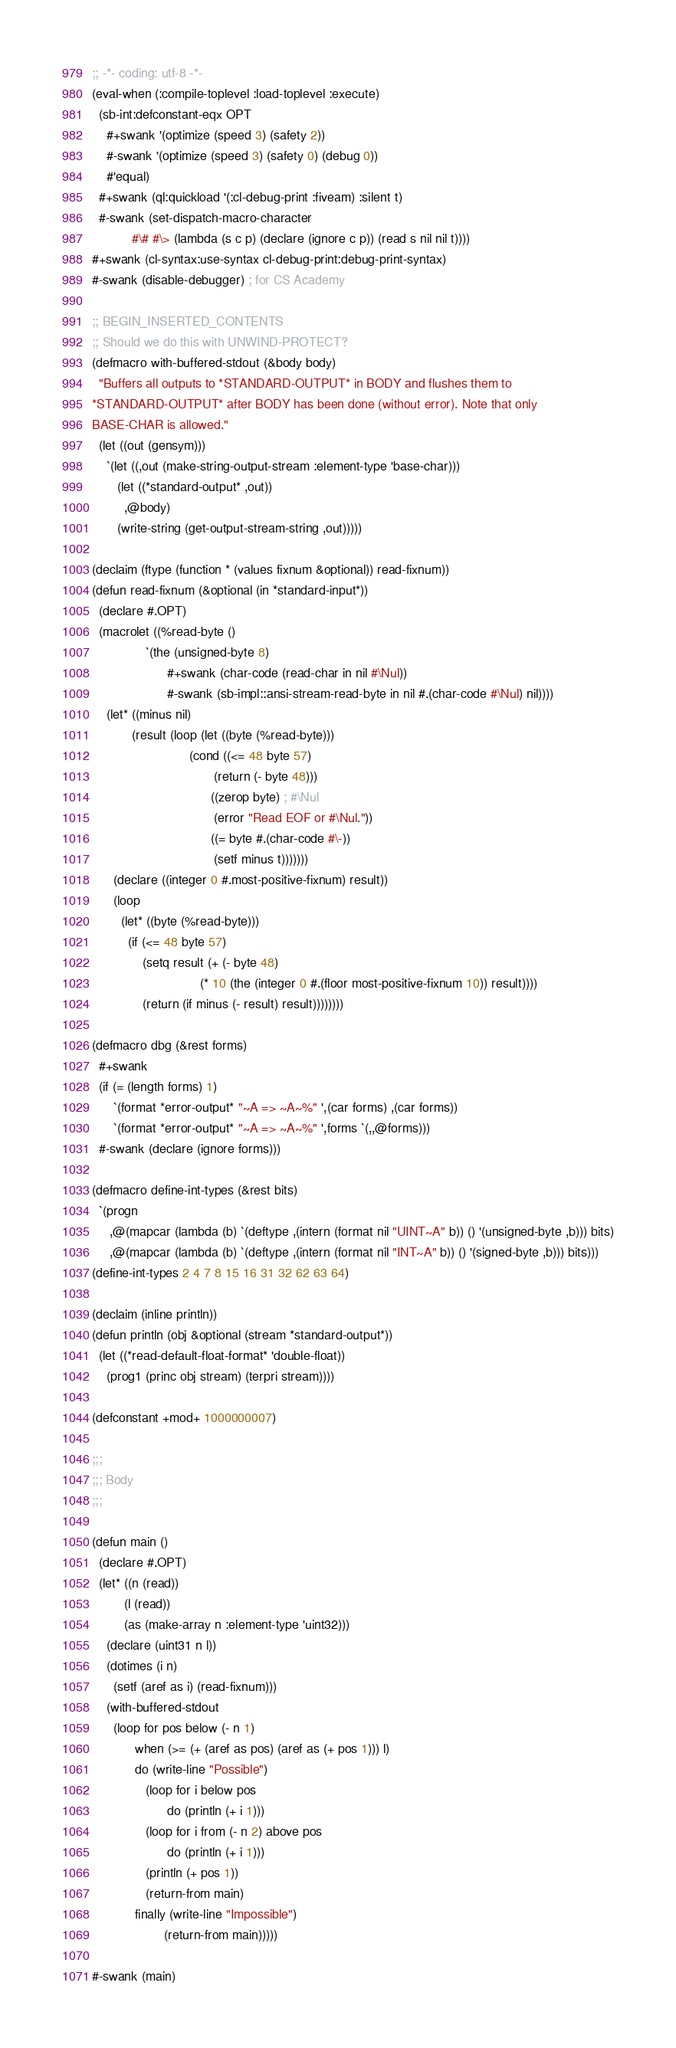<code> <loc_0><loc_0><loc_500><loc_500><_Lisp_>;; -*- coding: utf-8 -*-
(eval-when (:compile-toplevel :load-toplevel :execute)
  (sb-int:defconstant-eqx OPT
    #+swank '(optimize (speed 3) (safety 2))
    #-swank '(optimize (speed 3) (safety 0) (debug 0))
    #'equal)
  #+swank (ql:quickload '(:cl-debug-print :fiveam) :silent t)
  #-swank (set-dispatch-macro-character
           #\# #\> (lambda (s c p) (declare (ignore c p)) (read s nil nil t))))
#+swank (cl-syntax:use-syntax cl-debug-print:debug-print-syntax)
#-swank (disable-debugger) ; for CS Academy

;; BEGIN_INSERTED_CONTENTS
;; Should we do this with UNWIND-PROTECT?
(defmacro with-buffered-stdout (&body body)
  "Buffers all outputs to *STANDARD-OUTPUT* in BODY and flushes them to
*STANDARD-OUTPUT* after BODY has been done (without error). Note that only
BASE-CHAR is allowed."
  (let ((out (gensym)))
    `(let ((,out (make-string-output-stream :element-type 'base-char)))
       (let ((*standard-output* ,out))
         ,@body)
       (write-string (get-output-stream-string ,out)))))

(declaim (ftype (function * (values fixnum &optional)) read-fixnum))
(defun read-fixnum (&optional (in *standard-input*))
  (declare #.OPT)
  (macrolet ((%read-byte ()
               `(the (unsigned-byte 8)
                     #+swank (char-code (read-char in nil #\Nul))
                     #-swank (sb-impl::ansi-stream-read-byte in nil #.(char-code #\Nul) nil))))
    (let* ((minus nil)
           (result (loop (let ((byte (%read-byte)))
                           (cond ((<= 48 byte 57)
                                  (return (- byte 48)))
                                 ((zerop byte) ; #\Nul
                                  (error "Read EOF or #\Nul."))
                                 ((= byte #.(char-code #\-))
                                  (setf minus t)))))))
      (declare ((integer 0 #.most-positive-fixnum) result))
      (loop
        (let* ((byte (%read-byte)))
          (if (<= 48 byte 57)
              (setq result (+ (- byte 48)
                              (* 10 (the (integer 0 #.(floor most-positive-fixnum 10)) result))))
              (return (if minus (- result) result))))))))

(defmacro dbg (&rest forms)
  #+swank
  (if (= (length forms) 1)
      `(format *error-output* "~A => ~A~%" ',(car forms) ,(car forms))
      `(format *error-output* "~A => ~A~%" ',forms `(,,@forms)))
  #-swank (declare (ignore forms)))

(defmacro define-int-types (&rest bits)
  `(progn
     ,@(mapcar (lambda (b) `(deftype ,(intern (format nil "UINT~A" b)) () '(unsigned-byte ,b))) bits)
     ,@(mapcar (lambda (b) `(deftype ,(intern (format nil "INT~A" b)) () '(signed-byte ,b))) bits)))
(define-int-types 2 4 7 8 15 16 31 32 62 63 64)

(declaim (inline println))
(defun println (obj &optional (stream *standard-output*))
  (let ((*read-default-float-format* 'double-float))
    (prog1 (princ obj stream) (terpri stream))))

(defconstant +mod+ 1000000007)

;;;
;;; Body
;;;

(defun main ()
  (declare #.OPT)
  (let* ((n (read))
         (l (read))
         (as (make-array n :element-type 'uint32)))
    (declare (uint31 n l))
    (dotimes (i n)
      (setf (aref as i) (read-fixnum)))
    (with-buffered-stdout
      (loop for pos below (- n 1)
            when (>= (+ (aref as pos) (aref as (+ pos 1))) l)
            do (write-line "Possible")
               (loop for i below pos
                     do (println (+ i 1)))
               (loop for i from (- n 2) above pos
                     do (println (+ i 1)))
               (println (+ pos 1))
               (return-from main)
            finally (write-line "Impossible")
                    (return-from main)))))

#-swank (main)
</code> 